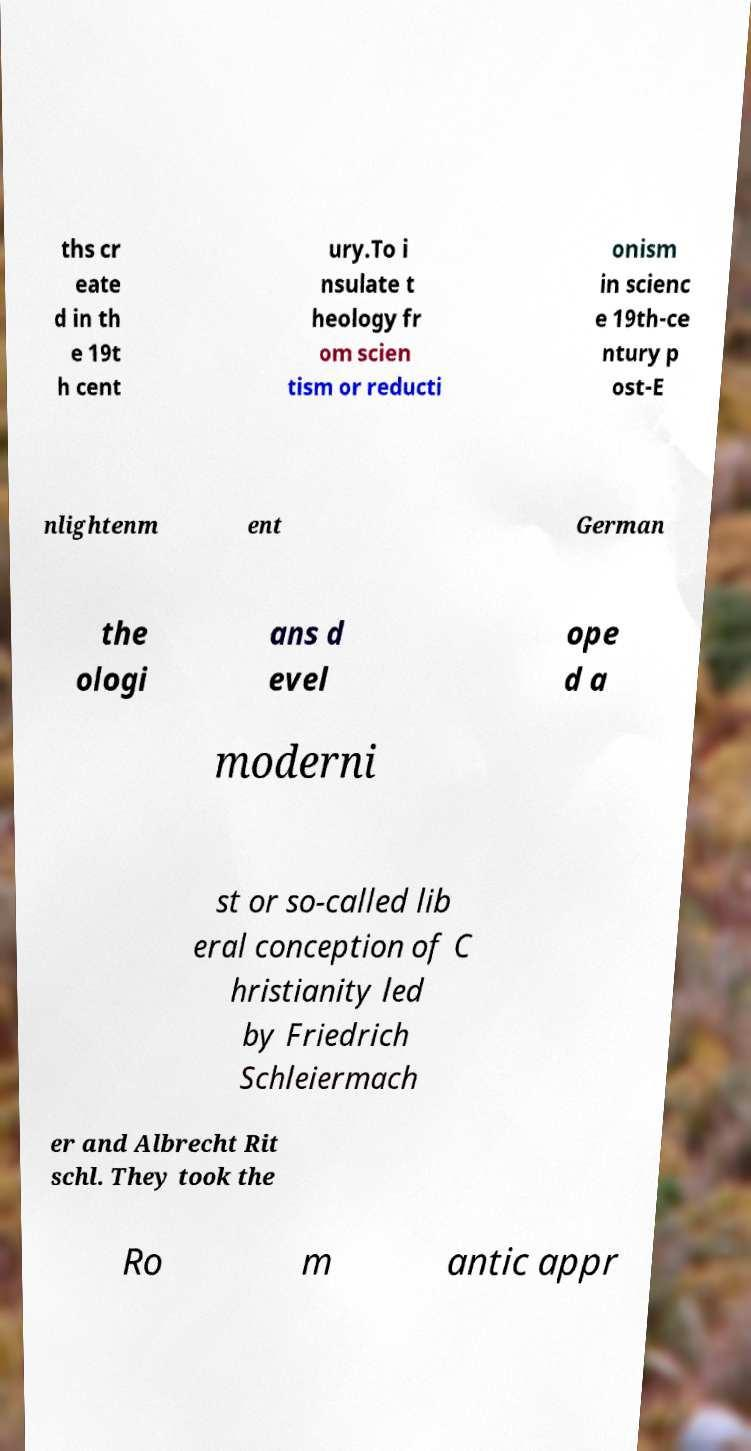Could you assist in decoding the text presented in this image and type it out clearly? ths cr eate d in th e 19t h cent ury.To i nsulate t heology fr om scien tism or reducti onism in scienc e 19th-ce ntury p ost-E nlightenm ent German the ologi ans d evel ope d a moderni st or so-called lib eral conception of C hristianity led by Friedrich Schleiermach er and Albrecht Rit schl. They took the Ro m antic appr 